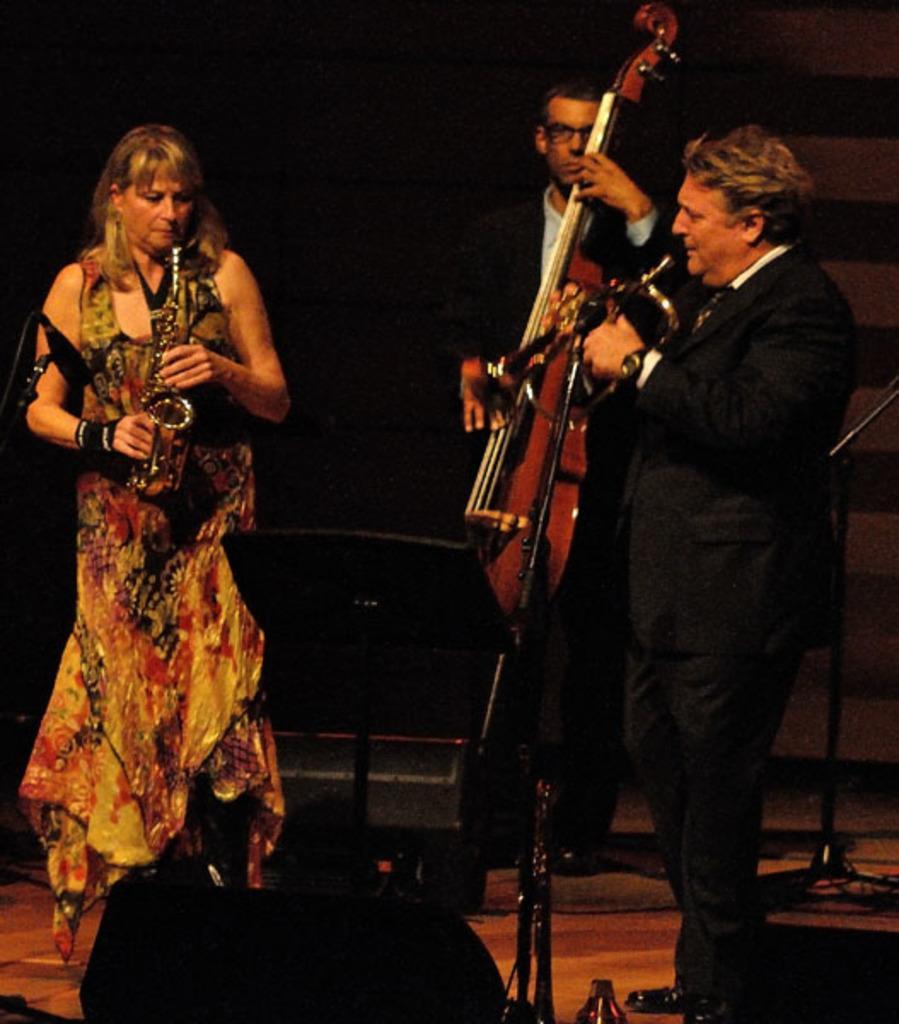In one or two sentences, can you explain what this image depicts? This image is taken in a concert. There are three people standing on the stage in this image, two men and a woman. In the left side of the image a woman is standing on the floor and playing the music with musical instrument. In the right side of the image a man is standing and at the back a man is standing holding a guitar in his hand. 